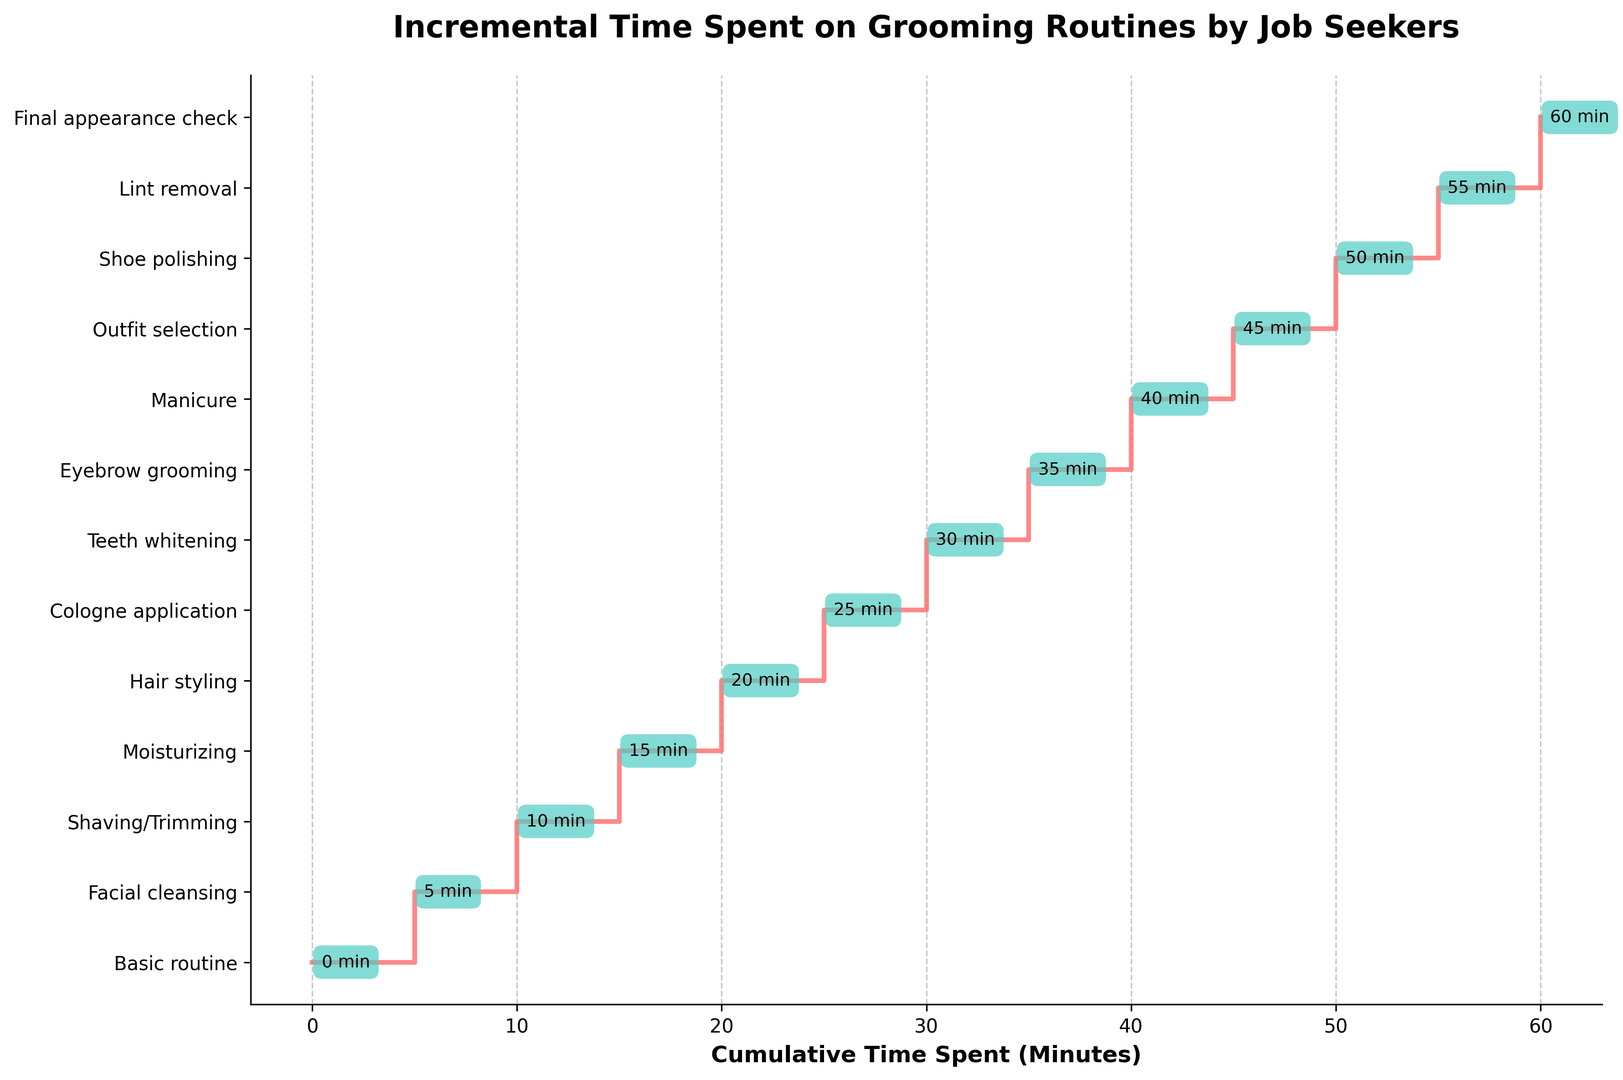What is the total cumulative time spent on all grooming activities? To find the total cumulative time, look at the highest point on the x-axis of the plot, which represents the final activity. The final cumulative time is 60 minutes.
Answer: 60 minutes Which activity takes place after 25 minutes have been spent? The y-axis labels the activities and the x-axis lists the cumulative time. After 25 minutes, the activity listed is "Teeth whitening."
Answer: Teeth whitening What is the difference in time spent on 'Hair styling' and 'Manicure'? 'Hair styling' occurs at 20 minutes, and 'Manicure' occurs at 40 minutes. The difference is 40 - 20 = 20 minutes.
Answer: 20 minutes How much time is spent on all activities before 'Eyebrow grooming'? 'Eyebrow grooming' occurs at 35 minutes. Before this, the activities up to 'Teeth whitening' are completed, which total 30 minutes.
Answer: 30 minutes Which two activities take the same amount of time to complete, 5 minutes each? By observing the cumulative times and the step heights, the transitions from 'Basic routine' to 'Facial cleansing' and 'Cologne application' to 'Teeth whitening' each take 5 minutes.
Answer: Facial cleansing and Cologne application to Teeth whitening What color is used to indicate the cumulative time annotations? The plot uses a specific color to highlight the annotations of time on each step. The annotations are enclosed in boxes colored in green.
Answer: Green At what cumulative time does 'Final appearance check' occur, and what is the total time difference from the 'Shaving/Trimming' activity? 'Final appearance check' is at 60 minutes, and 'Shaving/Trimming' occurs at 10 minutes. The time difference is 60 - 10 = 50 minutes.
Answer: 50 minutes What is the visual style used for representing the steps in the plot? The steps are represented using a specific line style and color. The line style is a step function with the color red.
Answer: Step function, red color Among 'Outfit selection' and 'Lint removal', which activity occurs first, and at what cumulative time? 'Outfit selection' is at 45 minutes, while 'Lint removal' is at 50 minutes. Therefore, 'Outfit selection' occurs first.
Answer: Outfit selection, 45 minutes If someone spends only 30 minutes on their routine, which activities will they have completed? By tracing cumulative times up to 30 minutes, the completed activities are 'Basic routine', 'Facial cleansing', 'Shaving/Trimming', 'Moisturizing', 'Hair styling', and 'Cologne application.
Answer: Basic routine, Facial cleansing, Shaving/Trimming, Moisturizing, Hair styling, Cologne application 